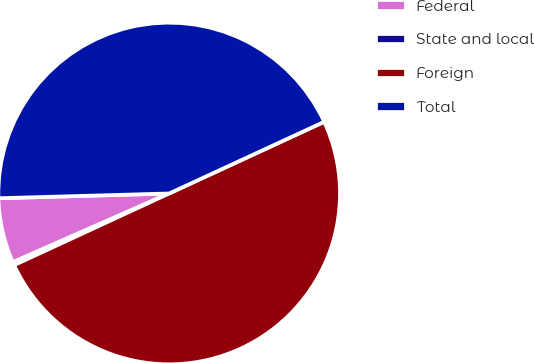Convert chart to OTSL. <chart><loc_0><loc_0><loc_500><loc_500><pie_chart><fcel>Federal<fcel>State and local<fcel>Foreign<fcel>Total<nl><fcel>6.15%<fcel>0.3%<fcel>50.0%<fcel>43.55%<nl></chart> 